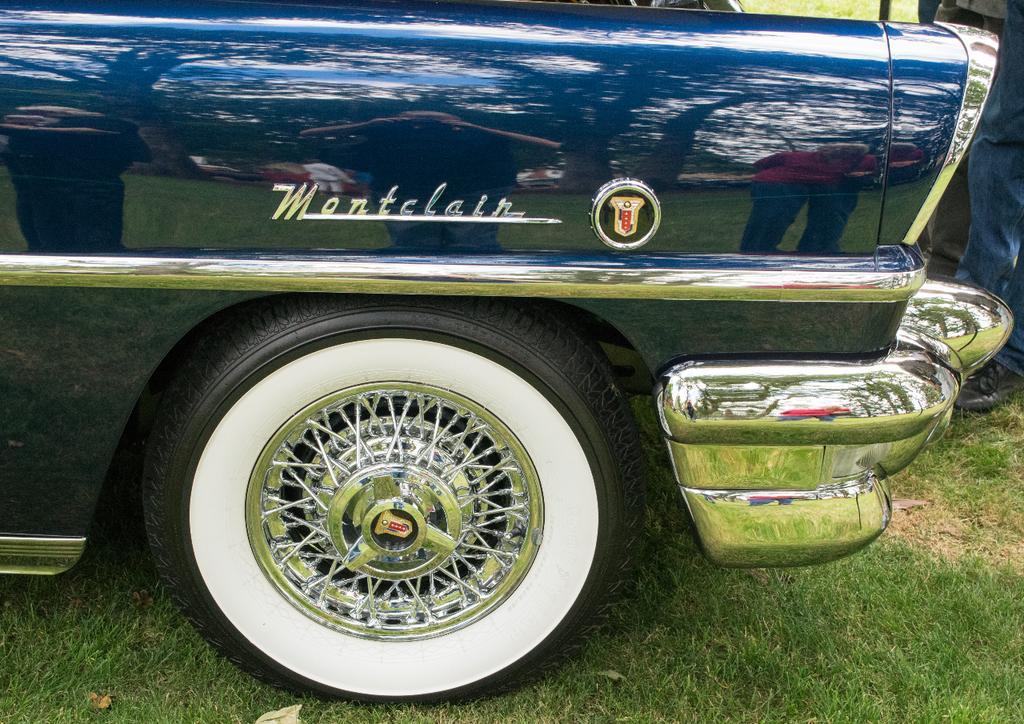Please provide a concise description of this image. In this picture we can see blue color car. On the bottom we can see grass. On the right we can see a person's leg who is wearing jeans and shoe. In the car´s reflection we can see a man who is holding a camera and trees. 